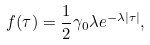Convert formula to latex. <formula><loc_0><loc_0><loc_500><loc_500>f ( \tau ) = \frac { 1 } { 2 } \gamma _ { 0 } \lambda e ^ { - \lambda | \tau | } ,</formula> 